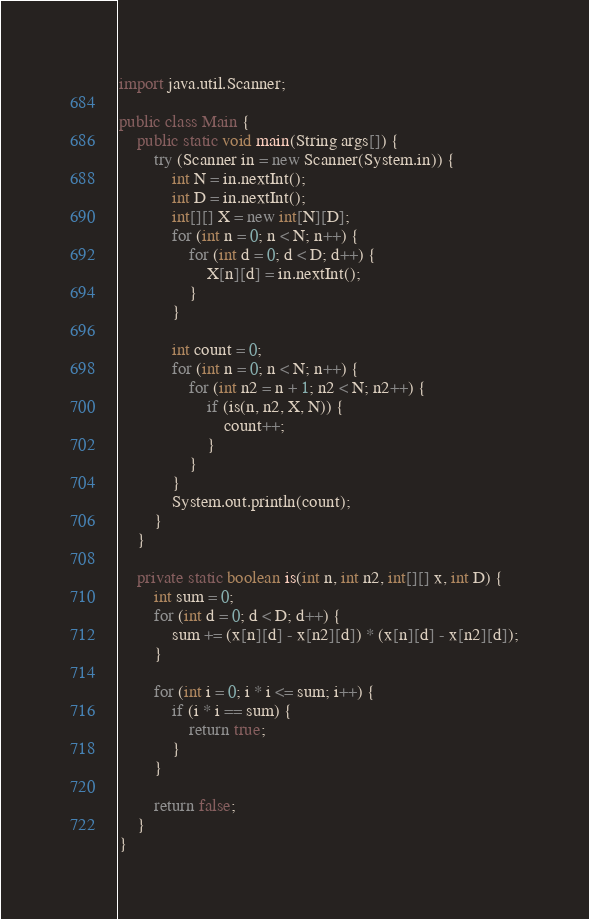Convert code to text. <code><loc_0><loc_0><loc_500><loc_500><_Java_>import java.util.Scanner;

public class Main {
    public static void main(String args[]) {
        try (Scanner in = new Scanner(System.in)) {
            int N = in.nextInt();
            int D = in.nextInt();
            int[][] X = new int[N][D];
            for (int n = 0; n < N; n++) {
                for (int d = 0; d < D; d++) {
                    X[n][d] = in.nextInt();
                }
            }

            int count = 0;
            for (int n = 0; n < N; n++) {
                for (int n2 = n + 1; n2 < N; n2++) {
                    if (is(n, n2, X, N)) {
                        count++;
                    }
                }
            }
            System.out.println(count);
        }
    }

    private static boolean is(int n, int n2, int[][] x, int D) {
        int sum = 0;
        for (int d = 0; d < D; d++) {
            sum += (x[n][d] - x[n2][d]) * (x[n][d] - x[n2][d]);
        }

        for (int i = 0; i * i <= sum; i++) {
            if (i * i == sum) {
                return true;
            }
        }

        return false;
    }
}
</code> 